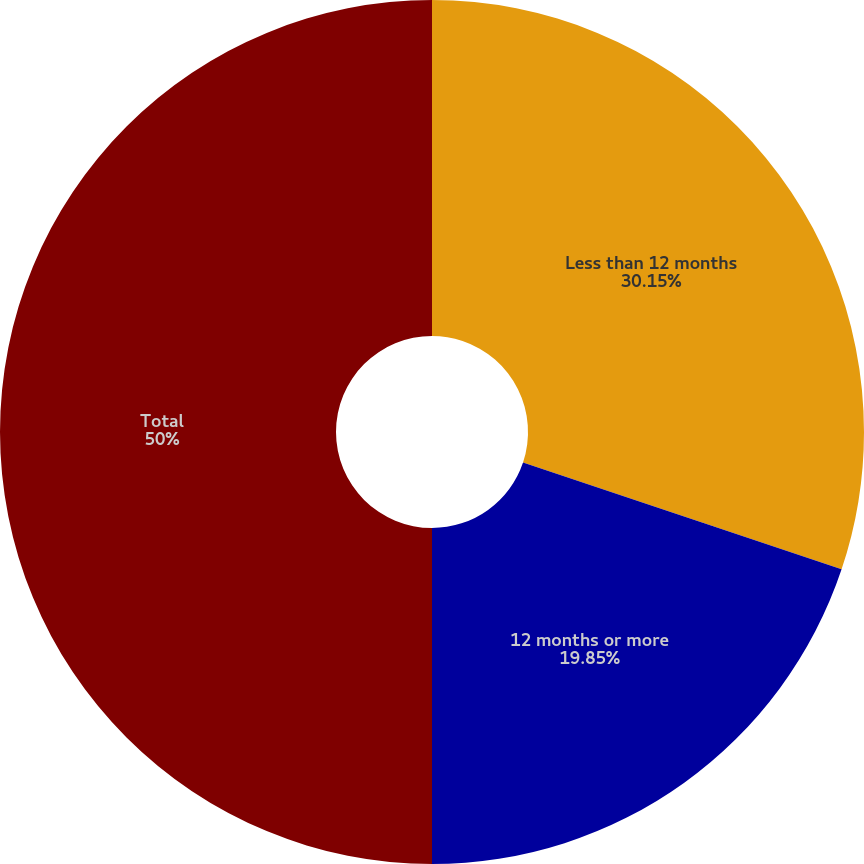Convert chart. <chart><loc_0><loc_0><loc_500><loc_500><pie_chart><fcel>Less than 12 months<fcel>12 months or more<fcel>Total<nl><fcel>30.15%<fcel>19.85%<fcel>50.0%<nl></chart> 